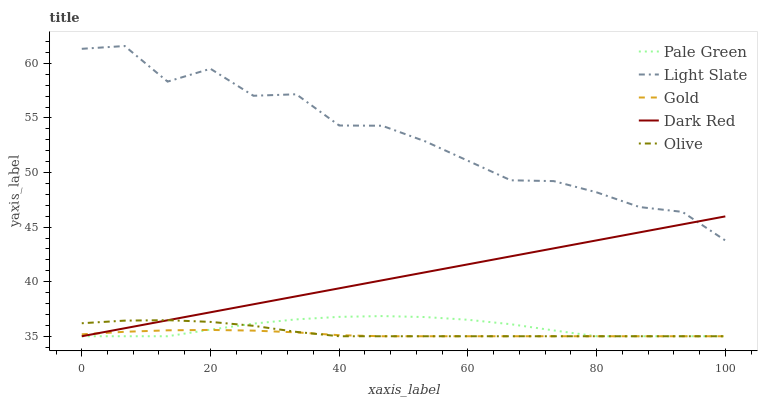Does Gold have the minimum area under the curve?
Answer yes or no. Yes. Does Light Slate have the maximum area under the curve?
Answer yes or no. Yes. Does Dark Red have the minimum area under the curve?
Answer yes or no. No. Does Dark Red have the maximum area under the curve?
Answer yes or no. No. Is Dark Red the smoothest?
Answer yes or no. Yes. Is Light Slate the roughest?
Answer yes or no. Yes. Is Pale Green the smoothest?
Answer yes or no. No. Is Pale Green the roughest?
Answer yes or no. No. Does Light Slate have the highest value?
Answer yes or no. Yes. Does Dark Red have the highest value?
Answer yes or no. No. Is Gold less than Light Slate?
Answer yes or no. Yes. Is Light Slate greater than Gold?
Answer yes or no. Yes. Does Gold intersect Pale Green?
Answer yes or no. Yes. Is Gold less than Pale Green?
Answer yes or no. No. Is Gold greater than Pale Green?
Answer yes or no. No. Does Gold intersect Light Slate?
Answer yes or no. No. 